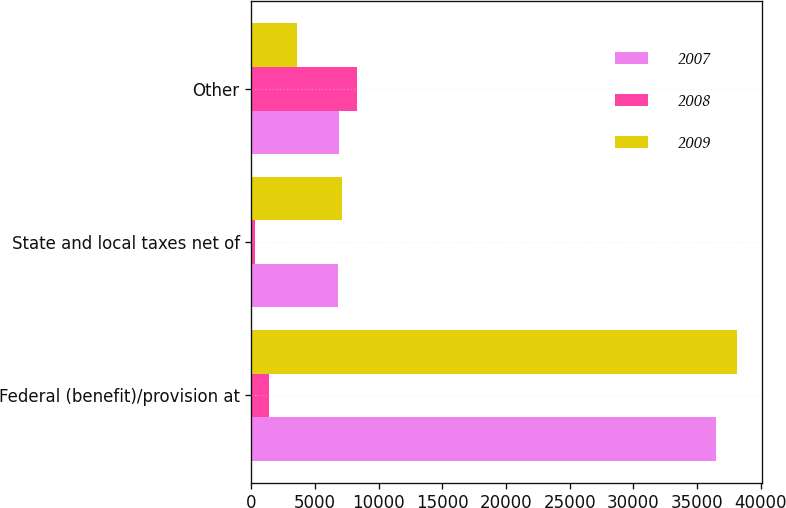Convert chart to OTSL. <chart><loc_0><loc_0><loc_500><loc_500><stacked_bar_chart><ecel><fcel>Federal (benefit)/provision at<fcel>State and local taxes net of<fcel>Other<nl><fcel>2007<fcel>36481<fcel>6775<fcel>6869<nl><fcel>2008<fcel>1390<fcel>258<fcel>8283<nl><fcel>2009<fcel>38170<fcel>7089<fcel>3552<nl></chart> 